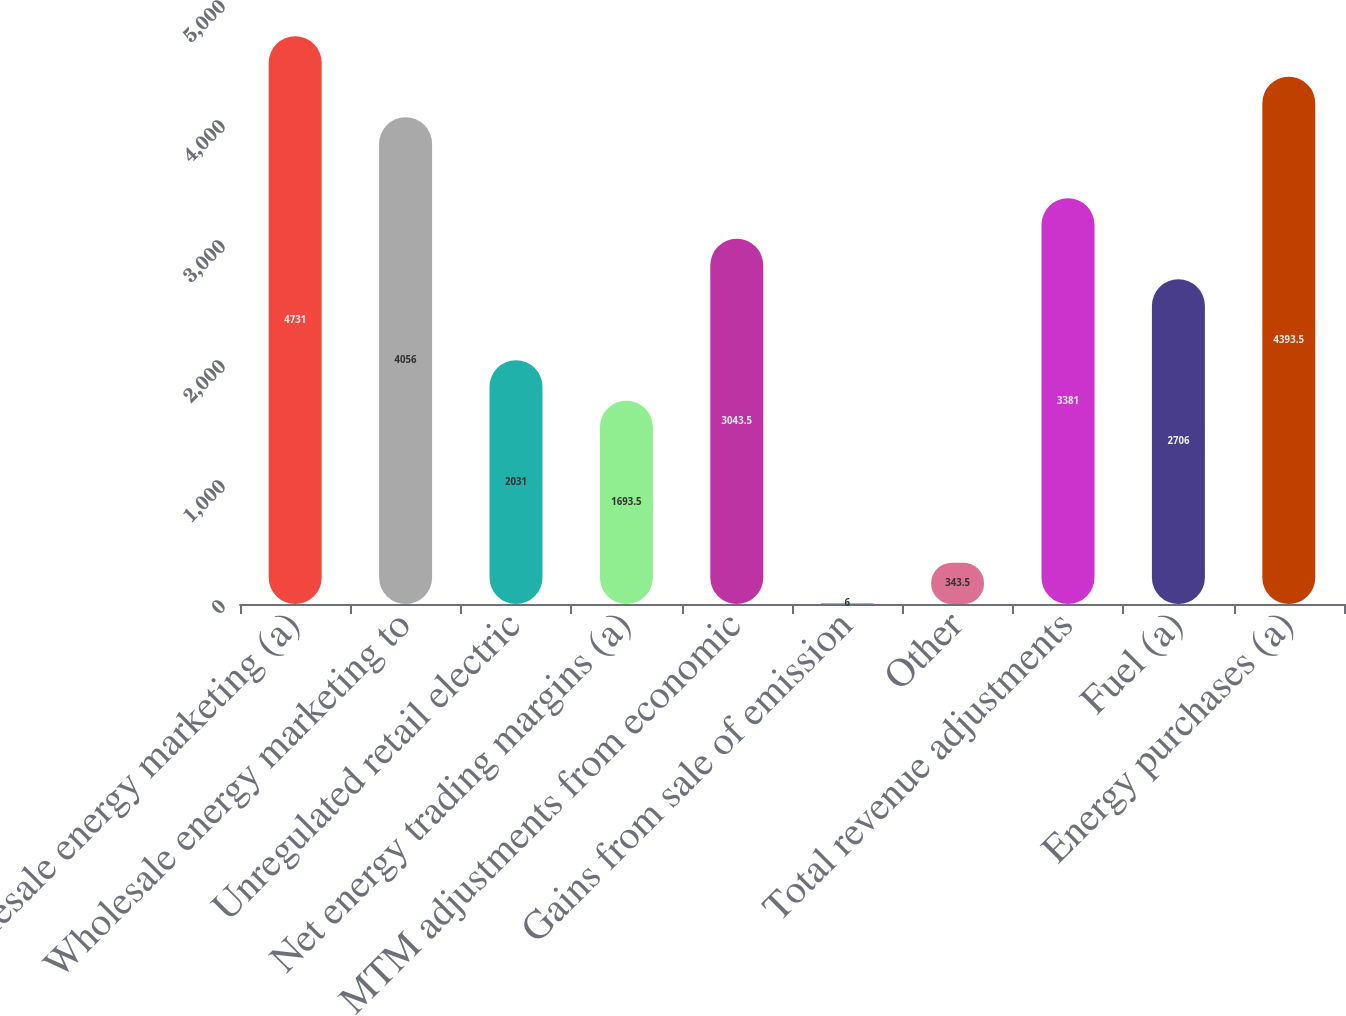Convert chart to OTSL. <chart><loc_0><loc_0><loc_500><loc_500><bar_chart><fcel>Wholesale energy marketing (a)<fcel>Wholesale energy marketing to<fcel>Unregulated retail electric<fcel>Net energy trading margins (a)<fcel>MTM adjustments from economic<fcel>Gains from sale of emission<fcel>Other<fcel>Total revenue adjustments<fcel>Fuel (a)<fcel>Energy purchases (a)<nl><fcel>4731<fcel>4056<fcel>2031<fcel>1693.5<fcel>3043.5<fcel>6<fcel>343.5<fcel>3381<fcel>2706<fcel>4393.5<nl></chart> 